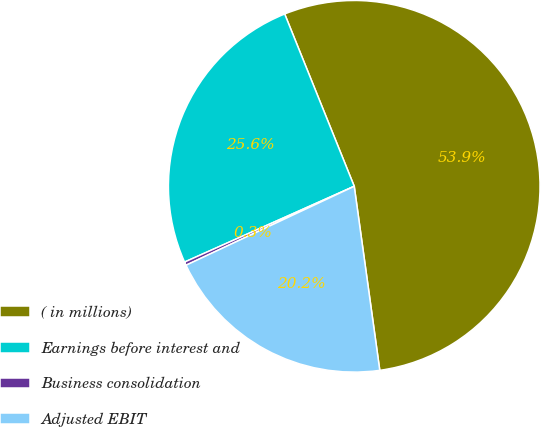Convert chart. <chart><loc_0><loc_0><loc_500><loc_500><pie_chart><fcel>( in millions)<fcel>Earnings before interest and<fcel>Business consolidation<fcel>Adjusted EBIT<nl><fcel>53.91%<fcel>25.58%<fcel>0.3%<fcel>20.21%<nl></chart> 